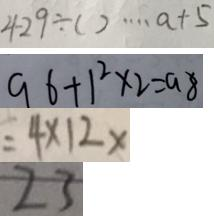<formula> <loc_0><loc_0><loc_500><loc_500>4 2 9 \div ( ) \cdots a + 5 
 9 6 + 1 ^ { 2 } \times 2 = 9 8 
 = 4 \times 1 2 x 
 2 3</formula> 